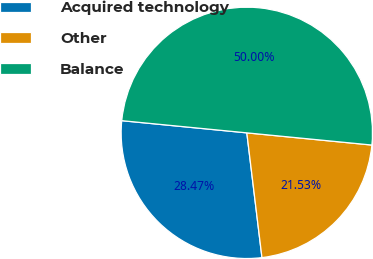Convert chart. <chart><loc_0><loc_0><loc_500><loc_500><pie_chart><fcel>Acquired technology<fcel>Other<fcel>Balance<nl><fcel>28.47%<fcel>21.53%<fcel>50.0%<nl></chart> 